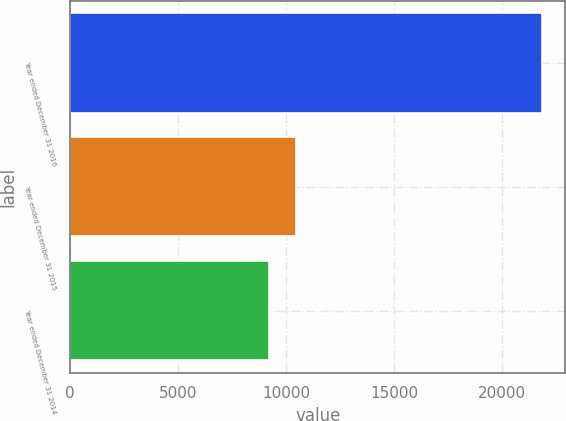Convert chart. <chart><loc_0><loc_0><loc_500><loc_500><bar_chart><fcel>Year ended December 31 2016<fcel>Year ended December 31 2015<fcel>Year ended December 31 2014<nl><fcel>21829<fcel>10448.5<fcel>9184<nl></chart> 